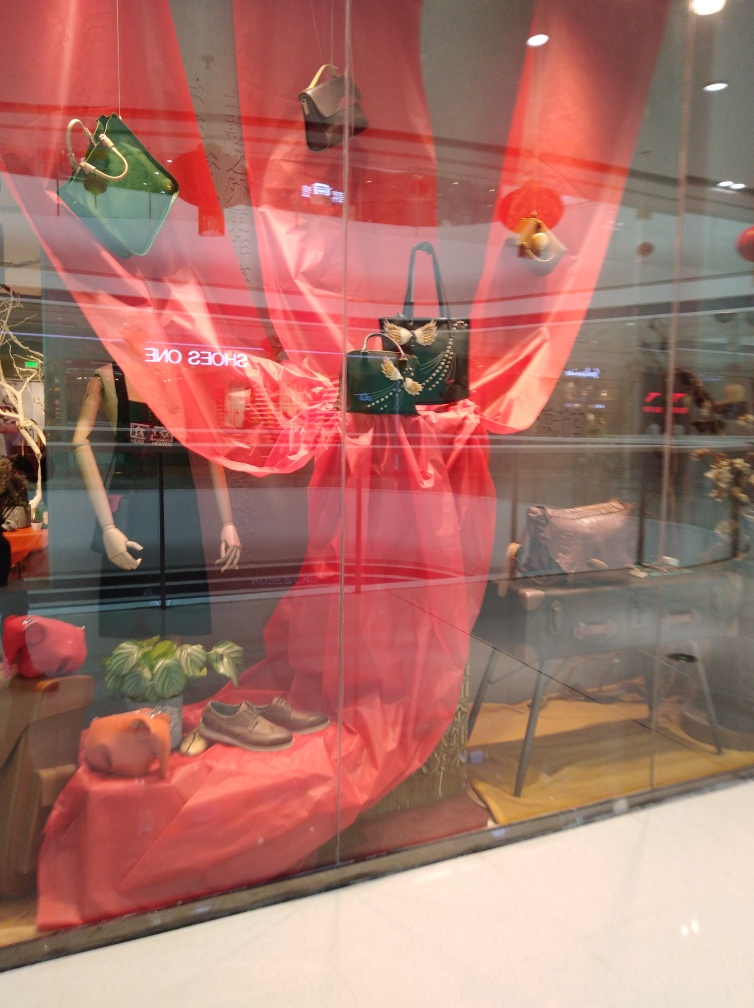What might be the theme of this display window? The theme of the window display appears to be centered around bold and vivid colors, especially red, which is used prominently in the backdrop fabric and contrasts with the items. It suggests energy and passion, possibly aiming to catch the eye of passersby and evoke a sense of vibrancy associated with fashion. Do the reflections affect the visual merchandising of the display? Yes, the reflections on the window add an unintended visual layer that could distract viewers from the items. However, these same reflections can play into the window's allure, creating a sort of real-world connection that passersby can see themselves in, quite literally, thereby drawing them into the store's aesthetic. 